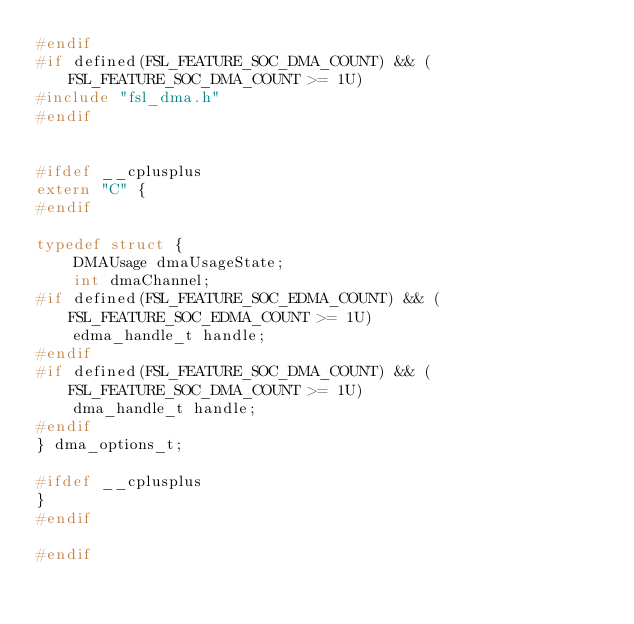<code> <loc_0><loc_0><loc_500><loc_500><_C_>#endif
#if defined(FSL_FEATURE_SOC_DMA_COUNT) && (FSL_FEATURE_SOC_DMA_COUNT >= 1U)
#include "fsl_dma.h"
#endif


#ifdef __cplusplus
extern "C" {
#endif

typedef struct {
    DMAUsage dmaUsageState;
    int dmaChannel;
#if defined(FSL_FEATURE_SOC_EDMA_COUNT) && (FSL_FEATURE_SOC_EDMA_COUNT >= 1U)
    edma_handle_t handle;
#endif
#if defined(FSL_FEATURE_SOC_DMA_COUNT) && (FSL_FEATURE_SOC_DMA_COUNT >= 1U)
    dma_handle_t handle;
#endif
} dma_options_t;

#ifdef __cplusplus
}
#endif

#endif
</code> 